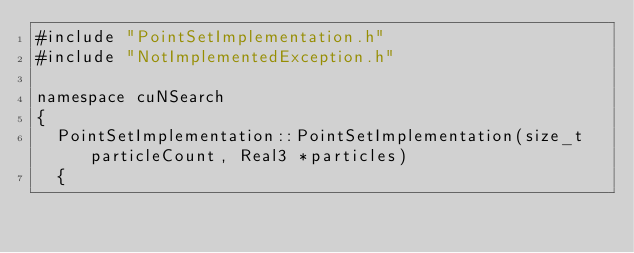<code> <loc_0><loc_0><loc_500><loc_500><_Cuda_>#include "PointSetImplementation.h"
#include "NotImplementedException.h"

namespace cuNSearch
{
	PointSetImplementation::PointSetImplementation(size_t particleCount, Real3 *particles)
	{</code> 